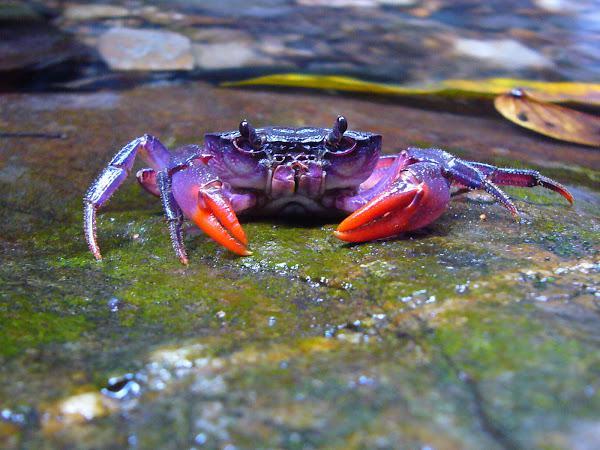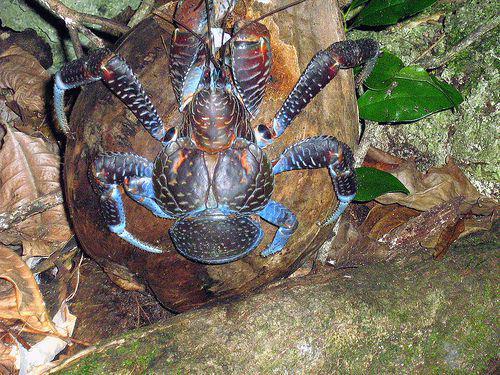The first image is the image on the left, the second image is the image on the right. Examine the images to the left and right. Is the description "Each image shows one purple crab with dark-tipped front claws that is facing the camera." accurate? Answer yes or no. No. The first image is the image on the left, the second image is the image on the right. For the images displayed, is the sentence "The tips of every crab's claws are noticeably black." factually correct? Answer yes or no. No. 